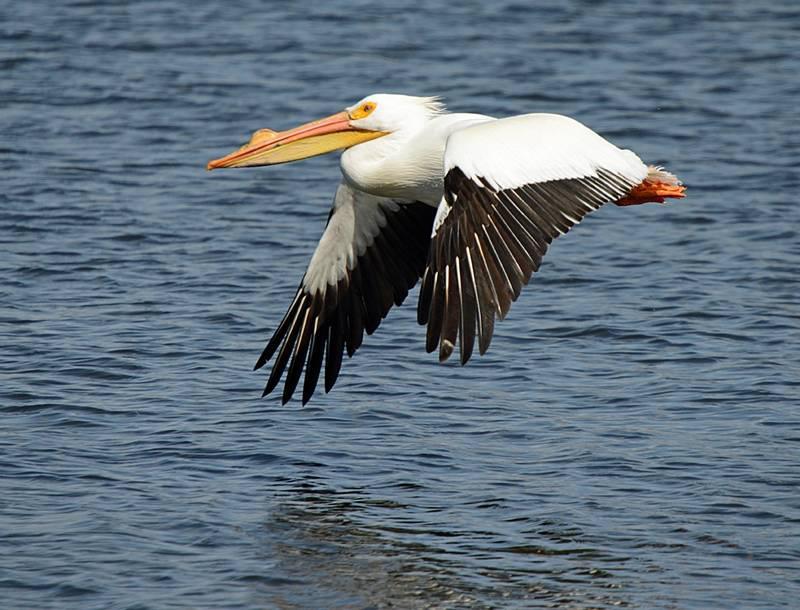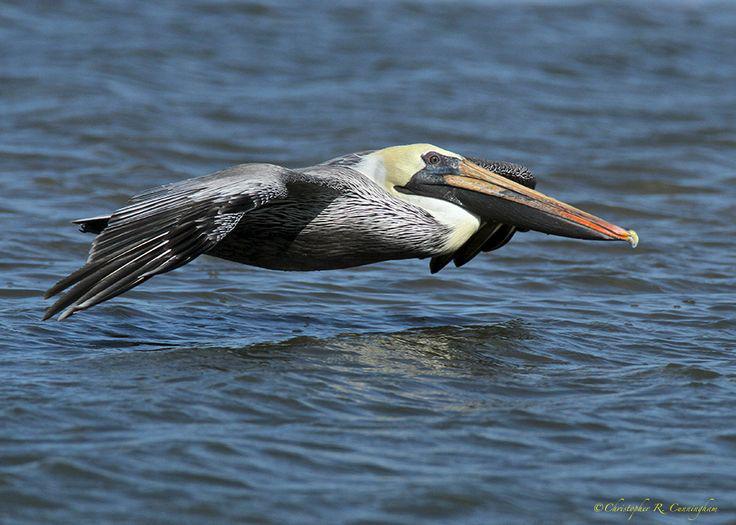The first image is the image on the left, the second image is the image on the right. Assess this claim about the two images: "Both of the birds are in the air above the water.". Correct or not? Answer yes or no. Yes. 